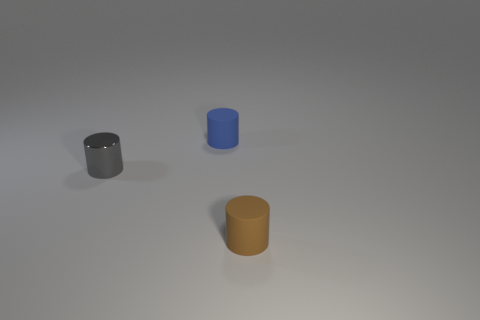Subtract all blue matte cylinders. How many cylinders are left? 2 Subtract all brown cylinders. How many cylinders are left? 2 Add 2 brown rubber things. How many objects exist? 5 Subtract 2 cylinders. How many cylinders are left? 1 Subtract all green cylinders. Subtract all green balls. How many cylinders are left? 3 Subtract all green spheres. How many gray cylinders are left? 1 Subtract all objects. Subtract all tiny green shiny things. How many objects are left? 0 Add 1 brown cylinders. How many brown cylinders are left? 2 Add 2 tiny metallic things. How many tiny metallic things exist? 3 Subtract 0 red balls. How many objects are left? 3 